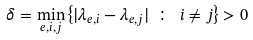Convert formula to latex. <formula><loc_0><loc_0><loc_500><loc_500>\delta = \min _ { e , i , j } \left \{ | \lambda _ { e , i } - \lambda _ { e , j } | \ \colon \ i \neq j \right \} > 0</formula> 